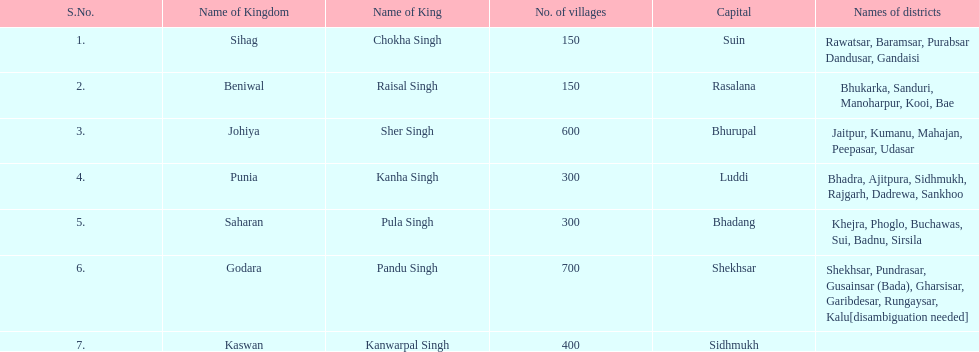He was the king of the sihag kingdom. Chokha Singh. 